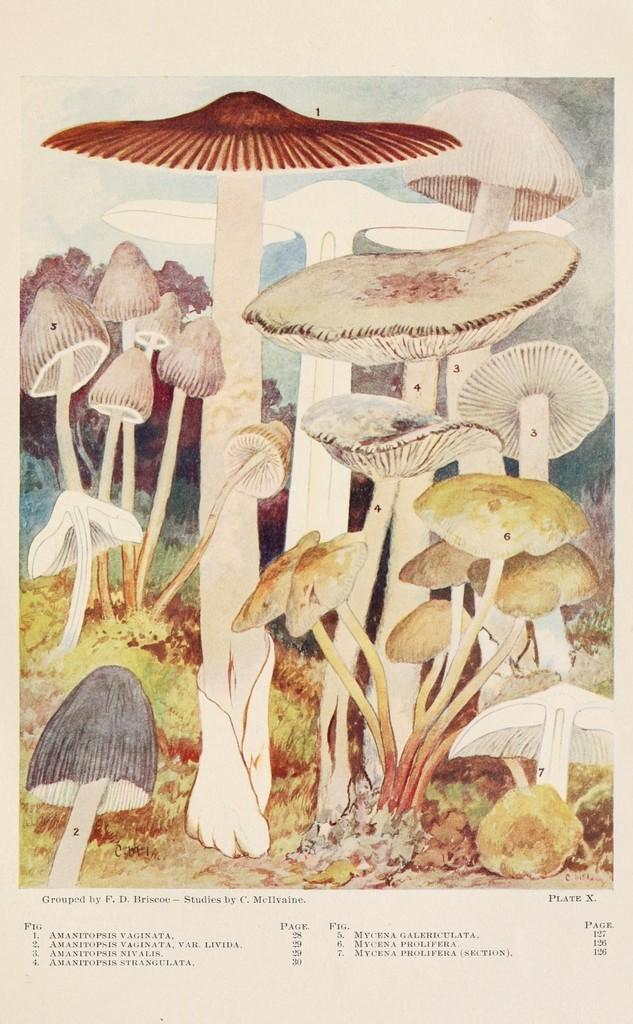What is the main subject of the image? The main subject of the image might be a painting. What can be seen in the center of the image? There are mushrooms in the center of the image. What type of vegetation is at the bottom of the image? There is grass and plants at the bottom of the image. What else is present at the bottom of the image? There is text at the bottom of the image. What type of structure is depicted in the center of the image? There is no structure depicted in the center of the image; it features mushrooms. Can you tell me how many circles are present in the image? There is no mention of circles in the image; it features mushrooms, grass, plants, and text. 